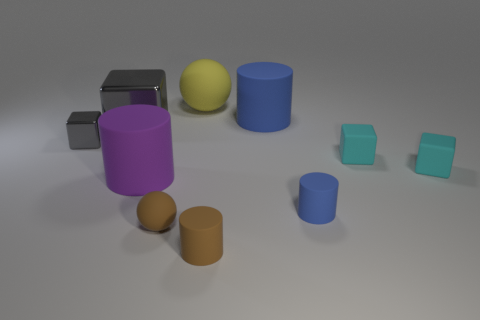What material is the yellow sphere?
Keep it short and to the point. Rubber. How many big yellow matte balls are in front of the small brown rubber cylinder?
Keep it short and to the point. 0. Do the cylinder that is in front of the small blue object and the large blue cylinder have the same material?
Your response must be concise. Yes. What number of small brown rubber things are the same shape as the purple rubber object?
Your answer should be compact. 1. How many large things are brown cylinders or red spheres?
Provide a short and direct response. 0. Is the color of the big cylinder behind the big gray thing the same as the small metal thing?
Offer a terse response. No. There is a cylinder that is in front of the tiny blue thing; is it the same color as the big rubber cylinder that is on the right side of the small brown cylinder?
Your answer should be very brief. No. Are there any big red cubes that have the same material as the small ball?
Offer a very short reply. No. What number of blue things are tiny metal cubes or large things?
Provide a short and direct response. 1. Is the number of blue objects that are to the left of the big blue cylinder greater than the number of large yellow rubber cubes?
Give a very brief answer. No. 